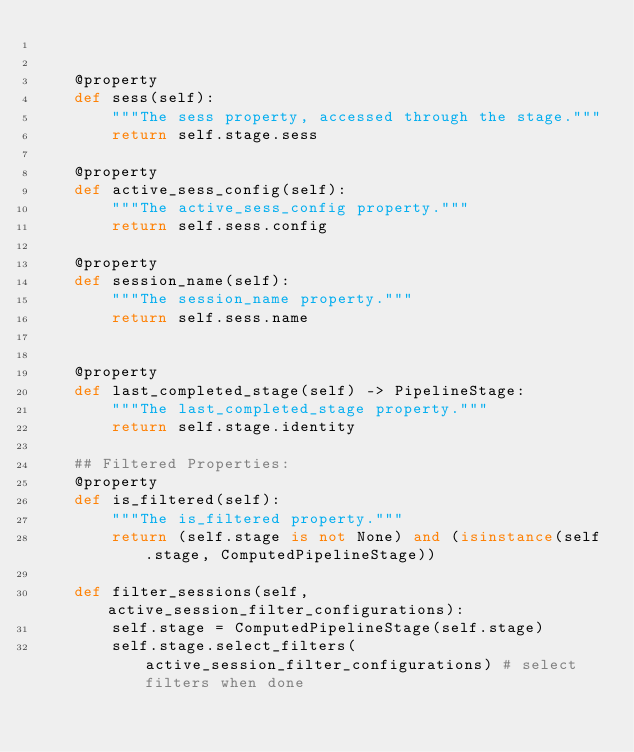Convert code to text. <code><loc_0><loc_0><loc_500><loc_500><_Python_>

    @property
    def sess(self):
        """The sess property, accessed through the stage."""
        return self.stage.sess

    @property
    def active_sess_config(self):
        """The active_sess_config property."""
        return self.sess.config

    @property
    def session_name(self):
        """The session_name property."""
        return self.sess.name

    
    @property
    def last_completed_stage(self) -> PipelineStage:
        """The last_completed_stage property."""
        return self.stage.identity
    
    ## Filtered Properties:
    @property
    def is_filtered(self):
        """The is_filtered property."""
        return (self.stage is not None) and (isinstance(self.stage, ComputedPipelineStage))
 
    def filter_sessions(self, active_session_filter_configurations):
        self.stage = ComputedPipelineStage(self.stage)
        self.stage.select_filters(active_session_filter_configurations) # select filters when done
       
    


</code> 